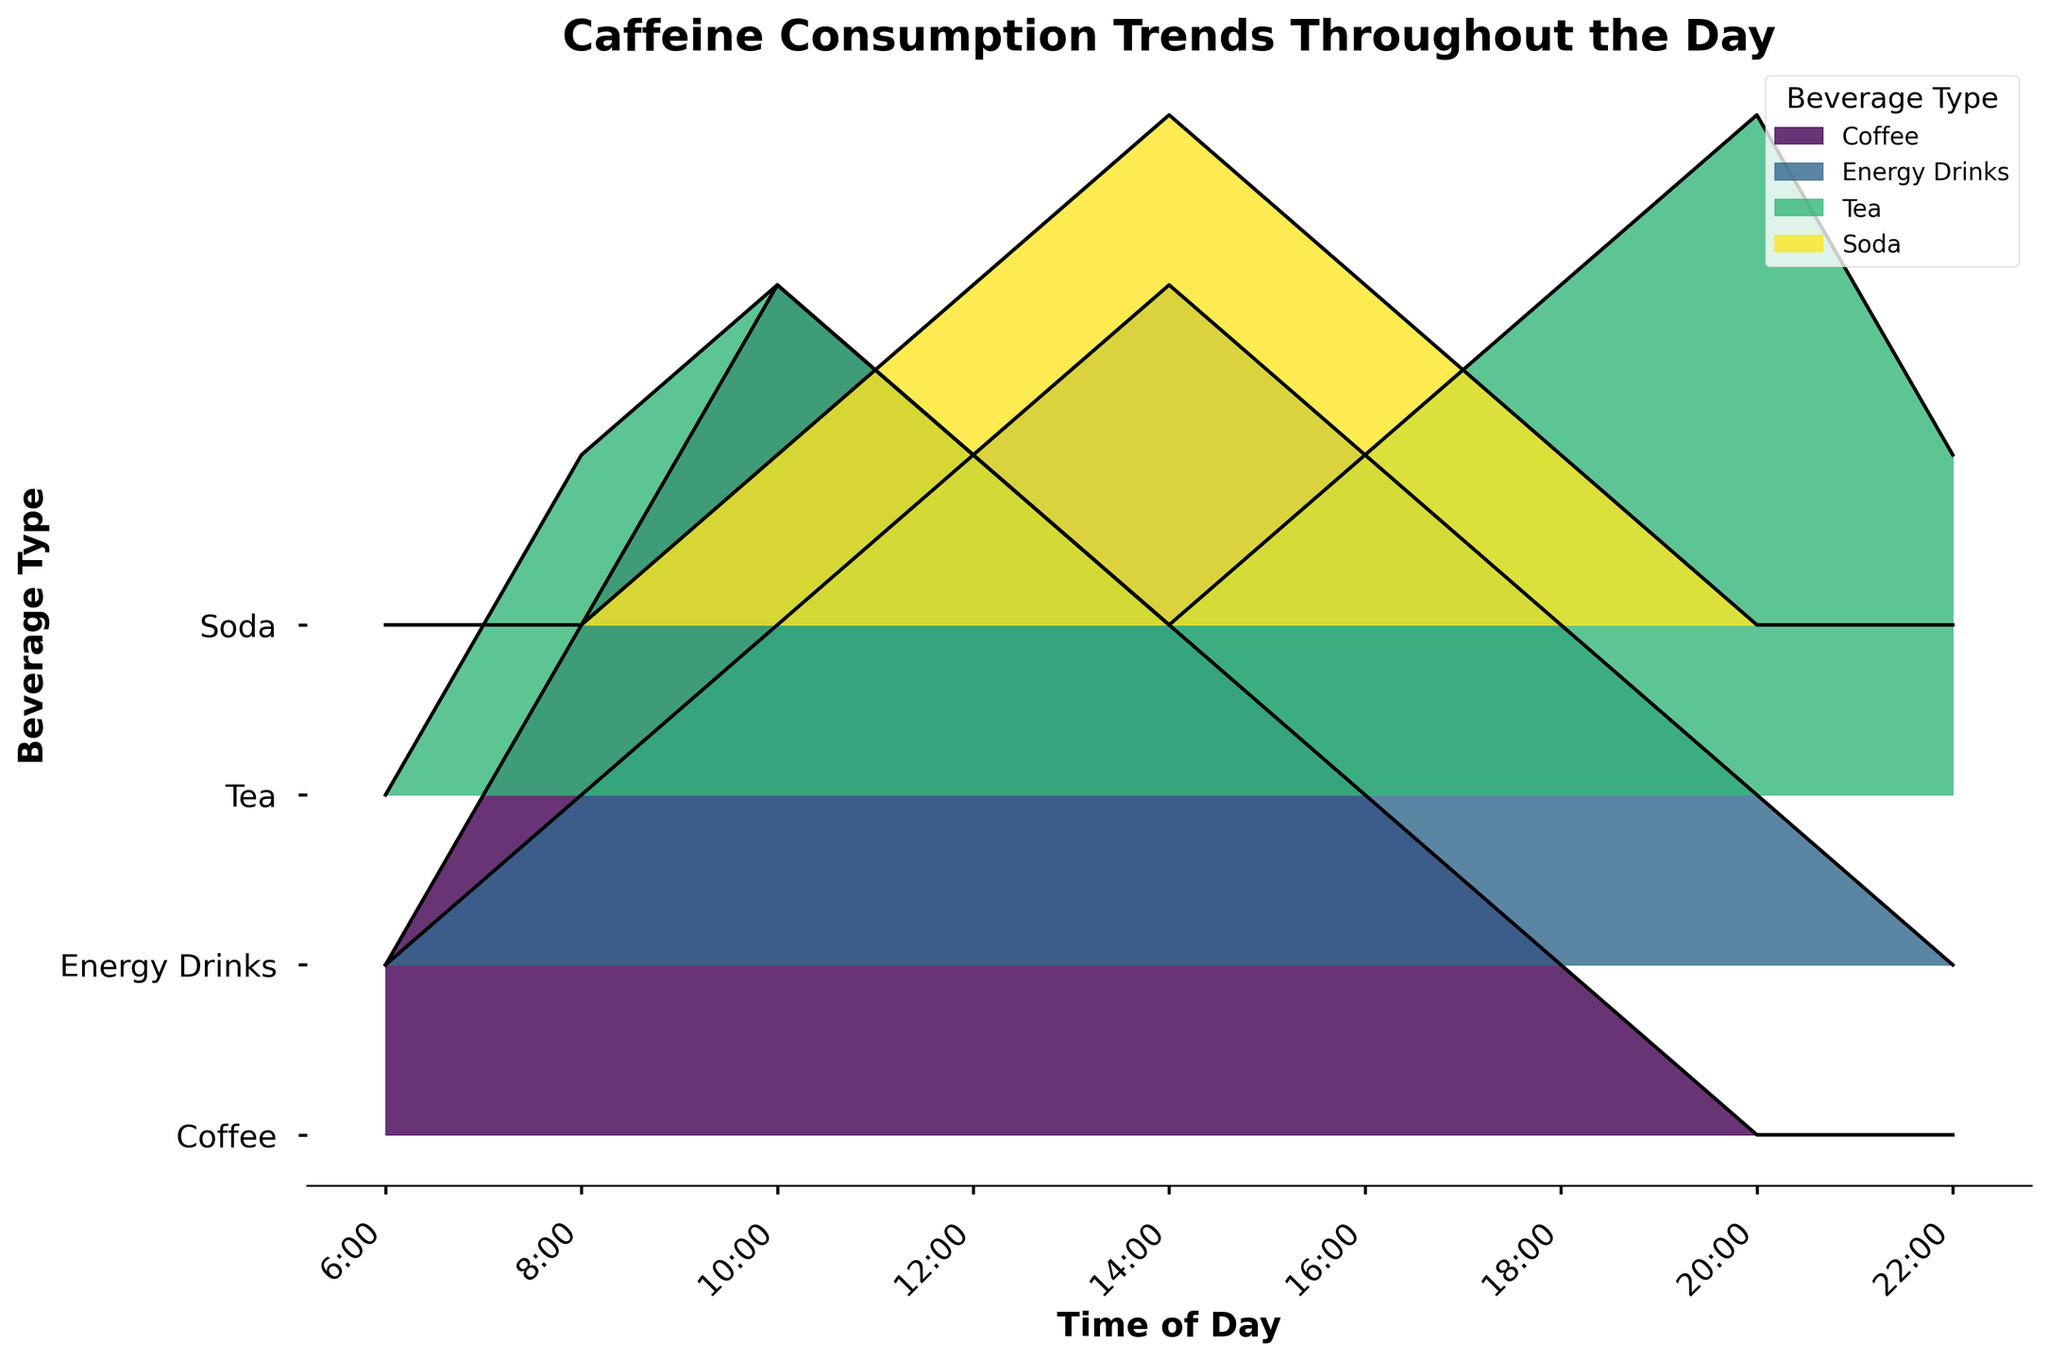What is the title of the figure? The title is typically located at the top of the plot and is a text that describes what the plot is about.
Answer: Caffeine Consumption Trends Throughout the Day Which beverage has the highest peak in caffeine consumption at 10:00? At 10:00, the plot shows different peaks for each beverage. The height of the peak indicates the level of consumption. Coffee has the highest peak at 10:00.
Answer: Coffee How many beverage types are plotted in the figure? The number of beverage types can be identified by counting the different categories represented on the y-axis labels. There are four labels.
Answer: 4 At what time do Energy Drinks show their highest caffeine consumption? Look for the highest point on the plot for the line corresponding to Energy Drinks. This peak occurs at 14:00.
Answer: 14:00 How does Soda consumption change from 6:00 to 14:00? Track the trend by following the line for Soda from 6:00, and observe the gradual changes in its height until 14:00. It increases from 0 to 3.
Answer: Increases Which beverage category shows an increase in consumption from 16:00 to 18:00? Follow the lines between 16:00 and 18:00 for each beverage. Tea shows an increase from 2 to 3.
Answer: Tea At 20:00, which beverage has the highest caffeine consumption? Check the heights of the lines at 20:00 for all beverages. Tea has the highest value with 4.
Answer: Tea What is the total number of caffeine consumption events for Tea throughout the day? Add the values for Tea at all time points: 0 + 2 + 3 + 2 + 1 + 2 + 3 + 4 + 2 = 19.
Answer: 19 Which beverage types have zeros in their consumption at certain times of the day? Identify lines on the plot that touch zero (the x-axis). Soda, Energy Drinks, and Tea all have periods of zero consumption.
Answer: Soda, Energy Drinks, Tea Compare the caffeine consumption trends for Coffee and Energy Drinks. What differences do you observe? Observe the patterns of peaks and valleys for both lines. Coffee peaks early at 10:00 and gradually decreases, while Energy Drinks increase towards the afternoon, peaking at 14:00.
Answer: Coffee peaks early, Energy Drinks peak in the afternoon 